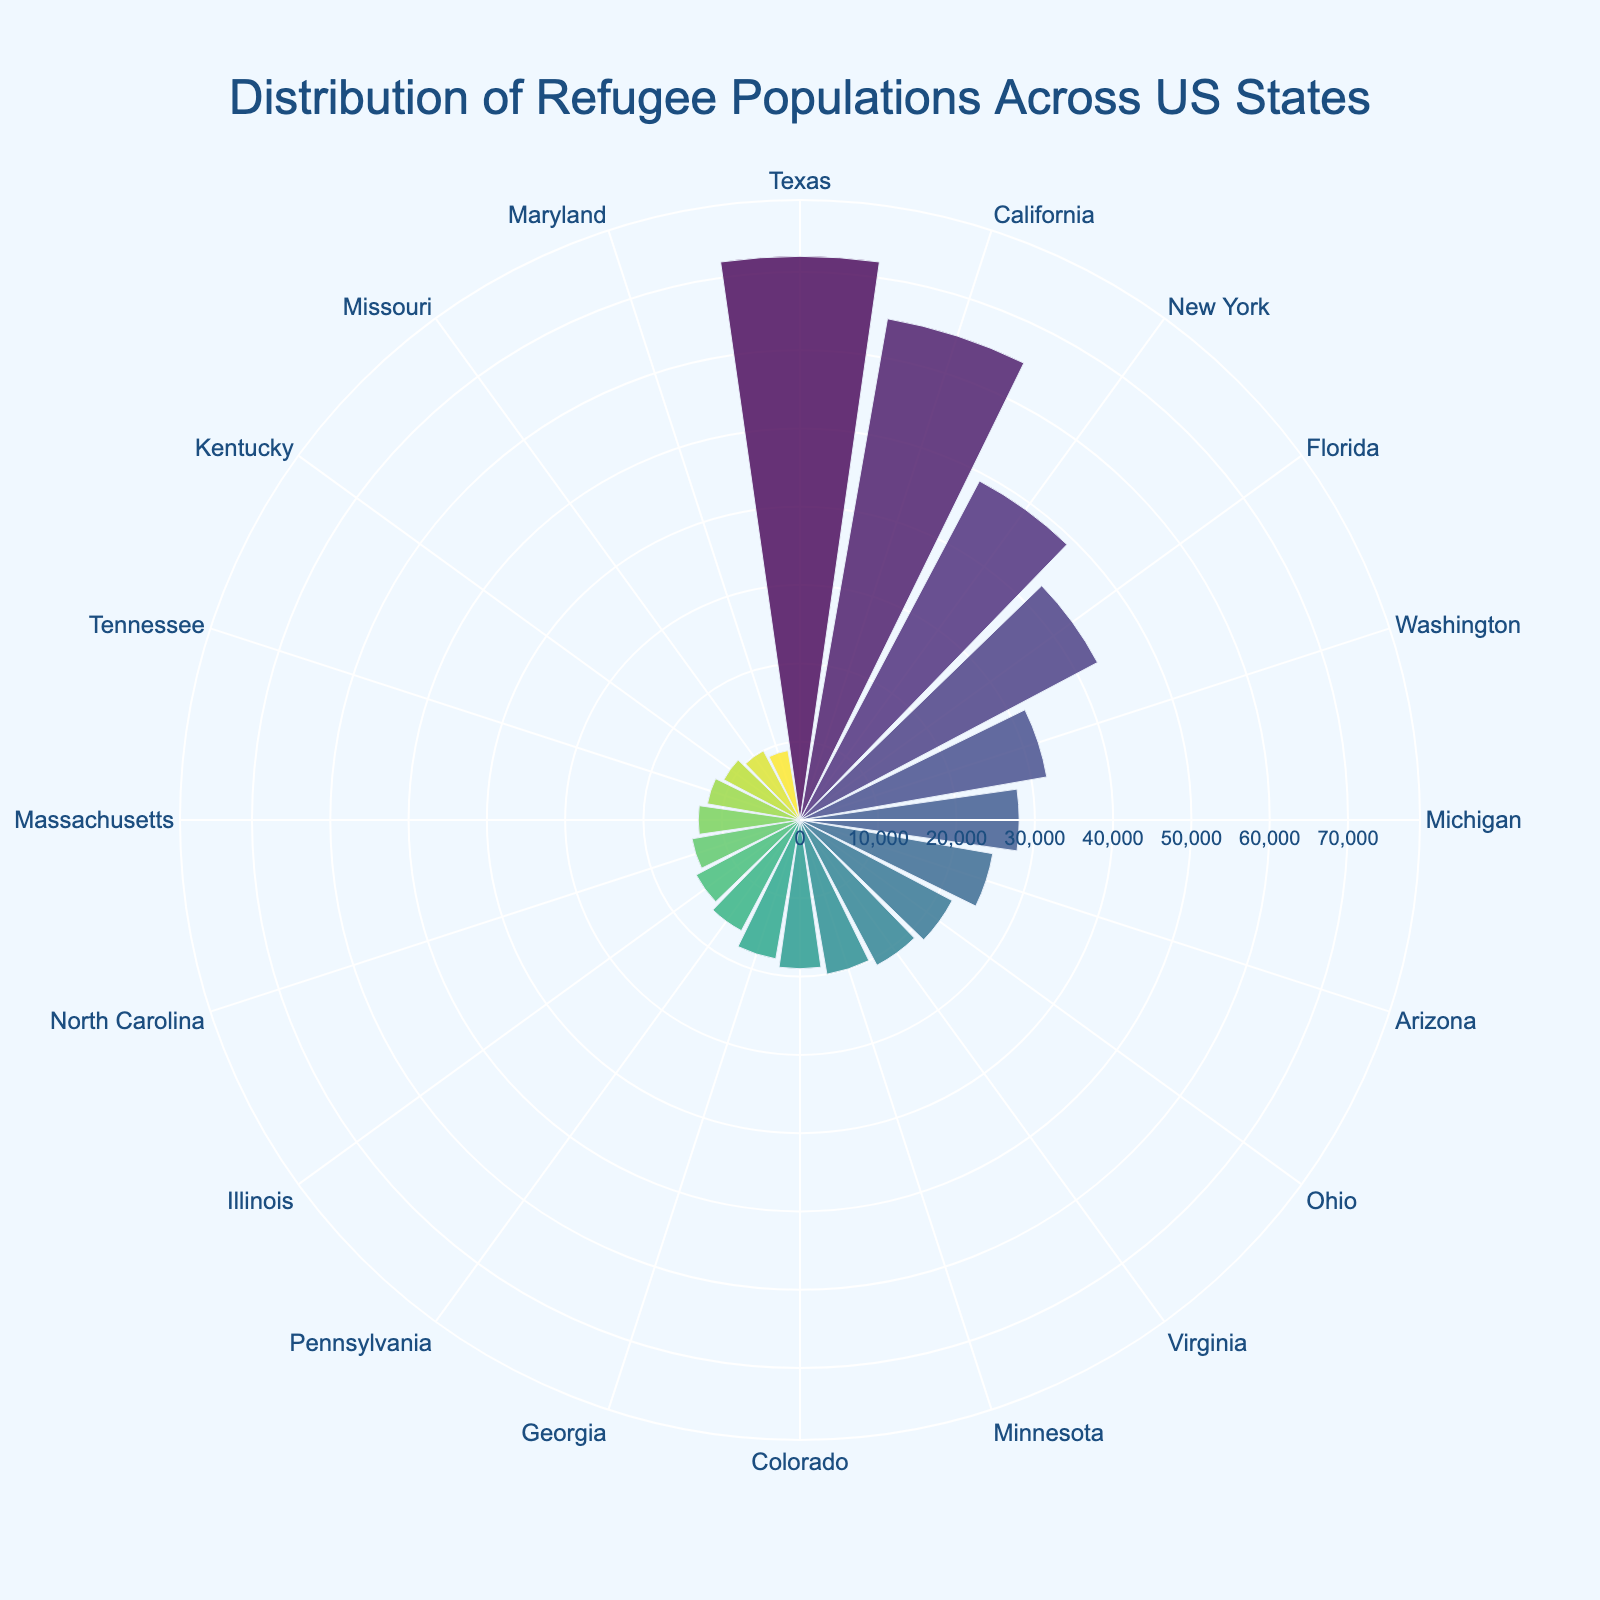What is the title of the chart? The chart title is prominently displayed at the top using a larger font size and a specific color, making it easy to read.
Answer: Distribution of Refugee Populations Across US States Which state has the largest refugee population? By observing the radial distance on the chart, which represents the refugee population, the state with the largest distance from the center can be determined.
Answer: Texas What is the refugee population in California? Hovering over the segment for California displays the refugee population as text. The color intensity and radial distance also support this information.
Answer: 65,000 How many states have a refugee population of 20,000 or more? By counting the segments where the radial distance is greater than or equal to 20,000, we can determine the number of states fitting this criterion.
Answer: 9 What is the difference in refugee population between New York and Florida? The refugee population for New York and Florida can be compared by looking at their respective radial distances and hover text, then subtracting the smaller from the larger.
Answer: 6,000 Which state has the smallest refugee population? The state with the smallest radial distance from the center represents the state with the smallest refugee population.
Answer: Maryland How does the refugee population of Washington compare to Michigan? By comparing the radial distances of Washington and Michigan, we can see which state has a larger refugee population.
Answer: Washington has a larger refugee population What pattern or color scale is used to represent the states? Observing the color gradation, it becomes clear that a Viridis color scale is used, ranging from dark purple to yellow.
Answer: Viridis color scale 